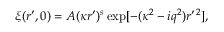<formula> <loc_0><loc_0><loc_500><loc_500>\xi ( r ^ { \prime } , 0 ) = A ( \kappa r ^ { \prime } ) ^ { s } \exp [ - ( \kappa ^ { 2 } - i q ^ { 2 } ) r ^ { \prime \, 2 } ] ,</formula> 